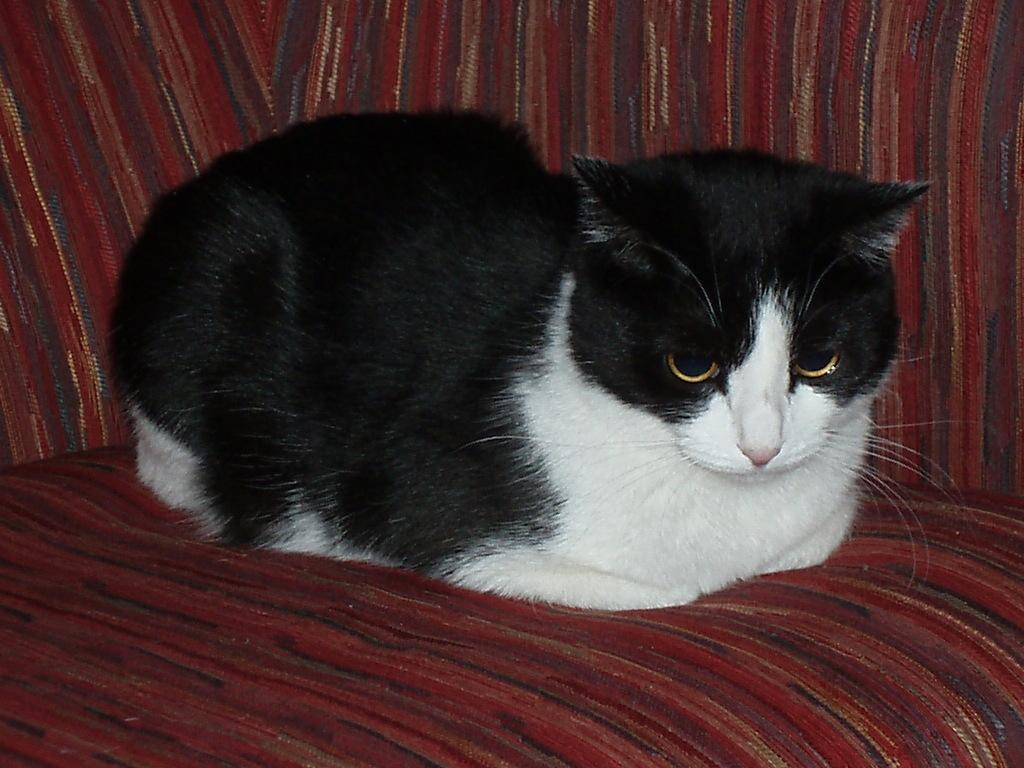What animal is present in the image? There is a cat in the image. Where is the cat located in the image? The cat is sitting on a couch. What type of spark can be seen coming from the cat in the image? There is no spark present in the image; it is a cat sitting on a couch. What kind of pest is the cat trying to catch in the image? There is no pest present in the image; it is a cat sitting on a couch. 